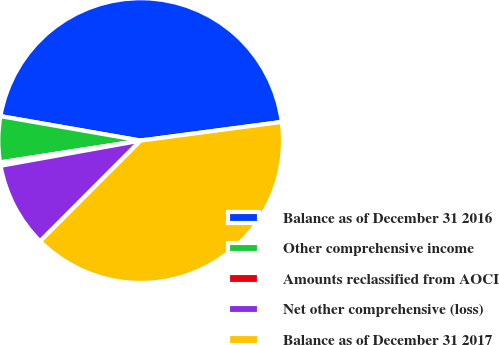<chart> <loc_0><loc_0><loc_500><loc_500><pie_chart><fcel>Balance as of December 31 2016<fcel>Other comprehensive income<fcel>Amounts reclassified from AOCI<fcel>Net other comprehensive (loss)<fcel>Balance as of December 31 2017<nl><fcel>45.16%<fcel>5.2%<fcel>0.38%<fcel>9.68%<fcel>39.58%<nl></chart> 